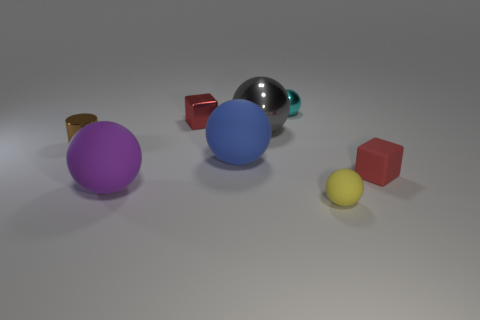Subtract all large rubber spheres. How many spheres are left? 3 Subtract all cyan balls. How many balls are left? 4 Add 2 cyan matte objects. How many objects exist? 10 Subtract all cubes. How many objects are left? 6 Subtract all brown spheres. Subtract all brown blocks. How many spheres are left? 5 Add 4 matte things. How many matte things are left? 8 Add 8 red blocks. How many red blocks exist? 10 Subtract 1 brown cylinders. How many objects are left? 7 Subtract all red metal balls. Subtract all red things. How many objects are left? 6 